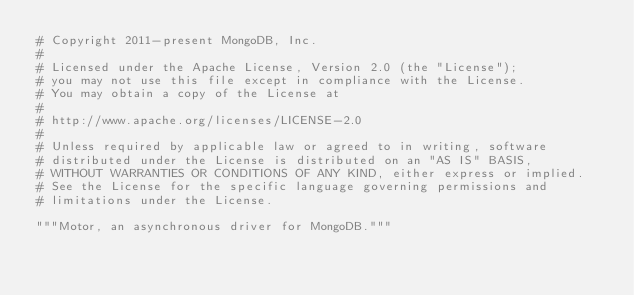<code> <loc_0><loc_0><loc_500><loc_500><_Python_># Copyright 2011-present MongoDB, Inc.
#
# Licensed under the Apache License, Version 2.0 (the "License");
# you may not use this file except in compliance with the License.
# You may obtain a copy of the License at
#
# http://www.apache.org/licenses/LICENSE-2.0
#
# Unless required by applicable law or agreed to in writing, software
# distributed under the License is distributed on an "AS IS" BASIS,
# WITHOUT WARRANTIES OR CONDITIONS OF ANY KIND, either express or implied.
# See the License for the specific language governing permissions and
# limitations under the License.

"""Motor, an asynchronous driver for MongoDB."""
</code> 